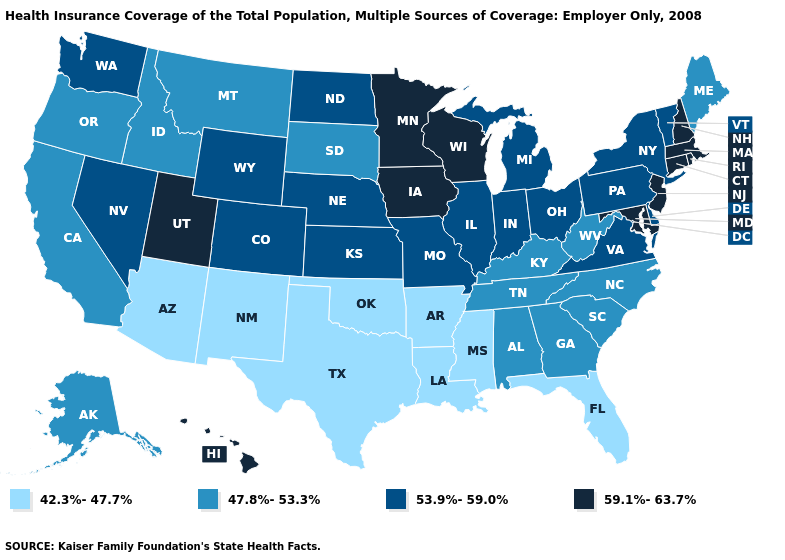What is the value of Maine?
Write a very short answer. 47.8%-53.3%. What is the lowest value in the USA?
Quick response, please. 42.3%-47.7%. Among the states that border West Virginia , does Maryland have the highest value?
Quick response, please. Yes. What is the value of Virginia?
Quick response, please. 53.9%-59.0%. Which states have the highest value in the USA?
Write a very short answer. Connecticut, Hawaii, Iowa, Maryland, Massachusetts, Minnesota, New Hampshire, New Jersey, Rhode Island, Utah, Wisconsin. What is the highest value in the USA?
Write a very short answer. 59.1%-63.7%. How many symbols are there in the legend?
Quick response, please. 4. What is the lowest value in the South?
Concise answer only. 42.3%-47.7%. What is the lowest value in states that border California?
Answer briefly. 42.3%-47.7%. Does Massachusetts have the lowest value in the Northeast?
Write a very short answer. No. Does Utah have the same value as Connecticut?
Write a very short answer. Yes. What is the value of Oklahoma?
Be succinct. 42.3%-47.7%. Does Virginia have a higher value than Texas?
Short answer required. Yes. What is the value of Alaska?
Be succinct. 47.8%-53.3%. What is the value of West Virginia?
Be succinct. 47.8%-53.3%. 